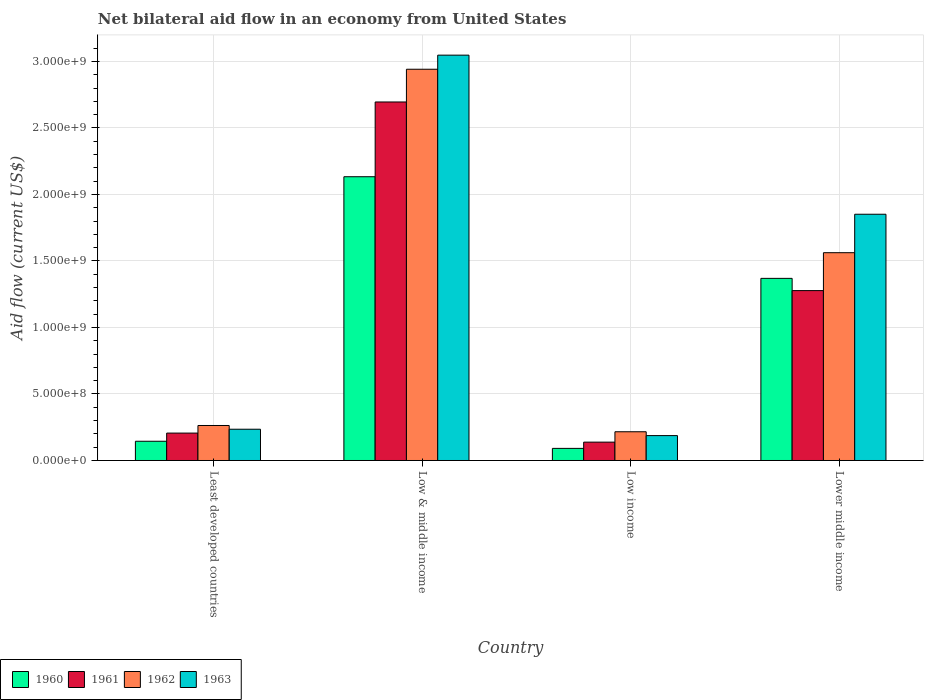How many different coloured bars are there?
Ensure brevity in your answer.  4. How many groups of bars are there?
Provide a short and direct response. 4. Are the number of bars per tick equal to the number of legend labels?
Offer a very short reply. Yes. Are the number of bars on each tick of the X-axis equal?
Offer a very short reply. Yes. How many bars are there on the 4th tick from the right?
Provide a succinct answer. 4. What is the label of the 2nd group of bars from the left?
Provide a short and direct response. Low & middle income. In how many cases, is the number of bars for a given country not equal to the number of legend labels?
Ensure brevity in your answer.  0. What is the net bilateral aid flow in 1962 in Least developed countries?
Keep it short and to the point. 2.63e+08. Across all countries, what is the maximum net bilateral aid flow in 1962?
Keep it short and to the point. 2.94e+09. Across all countries, what is the minimum net bilateral aid flow in 1960?
Give a very brief answer. 9.10e+07. In which country was the net bilateral aid flow in 1961 minimum?
Offer a terse response. Low income. What is the total net bilateral aid flow in 1963 in the graph?
Your answer should be compact. 5.32e+09. What is the difference between the net bilateral aid flow in 1963 in Least developed countries and that in Lower middle income?
Give a very brief answer. -1.62e+09. What is the difference between the net bilateral aid flow in 1960 in Low & middle income and the net bilateral aid flow in 1963 in Least developed countries?
Your answer should be compact. 1.90e+09. What is the average net bilateral aid flow in 1963 per country?
Provide a short and direct response. 1.33e+09. What is the difference between the net bilateral aid flow of/in 1962 and net bilateral aid flow of/in 1961 in Low & middle income?
Make the answer very short. 2.46e+08. In how many countries, is the net bilateral aid flow in 1962 greater than 2700000000 US$?
Give a very brief answer. 1. What is the ratio of the net bilateral aid flow in 1963 in Low & middle income to that in Lower middle income?
Your answer should be very brief. 1.65. What is the difference between the highest and the second highest net bilateral aid flow in 1960?
Your answer should be compact. 7.64e+08. What is the difference between the highest and the lowest net bilateral aid flow in 1960?
Provide a short and direct response. 2.04e+09. What does the 1st bar from the left in Lower middle income represents?
Offer a very short reply. 1960. What does the 4th bar from the right in Low income represents?
Ensure brevity in your answer.  1960. Is it the case that in every country, the sum of the net bilateral aid flow in 1960 and net bilateral aid flow in 1961 is greater than the net bilateral aid flow in 1963?
Provide a succinct answer. Yes. Are all the bars in the graph horizontal?
Ensure brevity in your answer.  No. How many countries are there in the graph?
Offer a very short reply. 4. What is the difference between two consecutive major ticks on the Y-axis?
Provide a short and direct response. 5.00e+08. How are the legend labels stacked?
Make the answer very short. Horizontal. What is the title of the graph?
Ensure brevity in your answer.  Net bilateral aid flow in an economy from United States. Does "1993" appear as one of the legend labels in the graph?
Your response must be concise. No. What is the label or title of the Y-axis?
Keep it short and to the point. Aid flow (current US$). What is the Aid flow (current US$) in 1960 in Least developed countries?
Offer a very short reply. 1.45e+08. What is the Aid flow (current US$) of 1961 in Least developed countries?
Give a very brief answer. 2.06e+08. What is the Aid flow (current US$) in 1962 in Least developed countries?
Your response must be concise. 2.63e+08. What is the Aid flow (current US$) of 1963 in Least developed countries?
Your answer should be compact. 2.35e+08. What is the Aid flow (current US$) in 1960 in Low & middle income?
Offer a very short reply. 2.13e+09. What is the Aid flow (current US$) of 1961 in Low & middle income?
Provide a succinct answer. 2.70e+09. What is the Aid flow (current US$) in 1962 in Low & middle income?
Make the answer very short. 2.94e+09. What is the Aid flow (current US$) of 1963 in Low & middle income?
Provide a succinct answer. 3.05e+09. What is the Aid flow (current US$) of 1960 in Low income?
Offer a very short reply. 9.10e+07. What is the Aid flow (current US$) in 1961 in Low income?
Give a very brief answer. 1.38e+08. What is the Aid flow (current US$) of 1962 in Low income?
Give a very brief answer. 2.16e+08. What is the Aid flow (current US$) in 1963 in Low income?
Give a very brief answer. 1.87e+08. What is the Aid flow (current US$) of 1960 in Lower middle income?
Provide a succinct answer. 1.37e+09. What is the Aid flow (current US$) of 1961 in Lower middle income?
Your answer should be very brief. 1.28e+09. What is the Aid flow (current US$) of 1962 in Lower middle income?
Your answer should be compact. 1.56e+09. What is the Aid flow (current US$) in 1963 in Lower middle income?
Offer a very short reply. 1.85e+09. Across all countries, what is the maximum Aid flow (current US$) of 1960?
Your answer should be very brief. 2.13e+09. Across all countries, what is the maximum Aid flow (current US$) of 1961?
Offer a very short reply. 2.70e+09. Across all countries, what is the maximum Aid flow (current US$) in 1962?
Your answer should be very brief. 2.94e+09. Across all countries, what is the maximum Aid flow (current US$) of 1963?
Make the answer very short. 3.05e+09. Across all countries, what is the minimum Aid flow (current US$) in 1960?
Offer a very short reply. 9.10e+07. Across all countries, what is the minimum Aid flow (current US$) in 1961?
Make the answer very short. 1.38e+08. Across all countries, what is the minimum Aid flow (current US$) of 1962?
Provide a succinct answer. 2.16e+08. Across all countries, what is the minimum Aid flow (current US$) in 1963?
Provide a succinct answer. 1.87e+08. What is the total Aid flow (current US$) in 1960 in the graph?
Ensure brevity in your answer.  3.74e+09. What is the total Aid flow (current US$) of 1961 in the graph?
Provide a succinct answer. 4.32e+09. What is the total Aid flow (current US$) of 1962 in the graph?
Your answer should be compact. 4.98e+09. What is the total Aid flow (current US$) in 1963 in the graph?
Offer a very short reply. 5.32e+09. What is the difference between the Aid flow (current US$) in 1960 in Least developed countries and that in Low & middle income?
Your answer should be compact. -1.99e+09. What is the difference between the Aid flow (current US$) in 1961 in Least developed countries and that in Low & middle income?
Ensure brevity in your answer.  -2.49e+09. What is the difference between the Aid flow (current US$) of 1962 in Least developed countries and that in Low & middle income?
Your response must be concise. -2.68e+09. What is the difference between the Aid flow (current US$) in 1963 in Least developed countries and that in Low & middle income?
Keep it short and to the point. -2.81e+09. What is the difference between the Aid flow (current US$) of 1960 in Least developed countries and that in Low income?
Ensure brevity in your answer.  5.35e+07. What is the difference between the Aid flow (current US$) of 1961 in Least developed countries and that in Low income?
Offer a terse response. 6.80e+07. What is the difference between the Aid flow (current US$) in 1962 in Least developed countries and that in Low income?
Your response must be concise. 4.70e+07. What is the difference between the Aid flow (current US$) in 1963 in Least developed countries and that in Low income?
Your response must be concise. 4.80e+07. What is the difference between the Aid flow (current US$) of 1960 in Least developed countries and that in Lower middle income?
Your answer should be compact. -1.22e+09. What is the difference between the Aid flow (current US$) of 1961 in Least developed countries and that in Lower middle income?
Offer a terse response. -1.07e+09. What is the difference between the Aid flow (current US$) of 1962 in Least developed countries and that in Lower middle income?
Keep it short and to the point. -1.30e+09. What is the difference between the Aid flow (current US$) in 1963 in Least developed countries and that in Lower middle income?
Ensure brevity in your answer.  -1.62e+09. What is the difference between the Aid flow (current US$) of 1960 in Low & middle income and that in Low income?
Offer a terse response. 2.04e+09. What is the difference between the Aid flow (current US$) of 1961 in Low & middle income and that in Low income?
Offer a terse response. 2.56e+09. What is the difference between the Aid flow (current US$) in 1962 in Low & middle income and that in Low income?
Give a very brief answer. 2.72e+09. What is the difference between the Aid flow (current US$) in 1963 in Low & middle income and that in Low income?
Your answer should be compact. 2.86e+09. What is the difference between the Aid flow (current US$) of 1960 in Low & middle income and that in Lower middle income?
Provide a succinct answer. 7.64e+08. What is the difference between the Aid flow (current US$) of 1961 in Low & middle income and that in Lower middle income?
Your answer should be very brief. 1.42e+09. What is the difference between the Aid flow (current US$) in 1962 in Low & middle income and that in Lower middle income?
Your response must be concise. 1.38e+09. What is the difference between the Aid flow (current US$) in 1963 in Low & middle income and that in Lower middle income?
Your answer should be very brief. 1.20e+09. What is the difference between the Aid flow (current US$) of 1960 in Low income and that in Lower middle income?
Keep it short and to the point. -1.28e+09. What is the difference between the Aid flow (current US$) in 1961 in Low income and that in Lower middle income?
Your response must be concise. -1.14e+09. What is the difference between the Aid flow (current US$) of 1962 in Low income and that in Lower middle income?
Ensure brevity in your answer.  -1.35e+09. What is the difference between the Aid flow (current US$) of 1963 in Low income and that in Lower middle income?
Keep it short and to the point. -1.66e+09. What is the difference between the Aid flow (current US$) in 1960 in Least developed countries and the Aid flow (current US$) in 1961 in Low & middle income?
Provide a short and direct response. -2.55e+09. What is the difference between the Aid flow (current US$) of 1960 in Least developed countries and the Aid flow (current US$) of 1962 in Low & middle income?
Ensure brevity in your answer.  -2.80e+09. What is the difference between the Aid flow (current US$) in 1960 in Least developed countries and the Aid flow (current US$) in 1963 in Low & middle income?
Your response must be concise. -2.90e+09. What is the difference between the Aid flow (current US$) of 1961 in Least developed countries and the Aid flow (current US$) of 1962 in Low & middle income?
Give a very brief answer. -2.74e+09. What is the difference between the Aid flow (current US$) of 1961 in Least developed countries and the Aid flow (current US$) of 1963 in Low & middle income?
Give a very brief answer. -2.84e+09. What is the difference between the Aid flow (current US$) of 1962 in Least developed countries and the Aid flow (current US$) of 1963 in Low & middle income?
Give a very brief answer. -2.78e+09. What is the difference between the Aid flow (current US$) in 1960 in Least developed countries and the Aid flow (current US$) in 1961 in Low income?
Provide a short and direct response. 6.52e+06. What is the difference between the Aid flow (current US$) in 1960 in Least developed countries and the Aid flow (current US$) in 1962 in Low income?
Offer a terse response. -7.15e+07. What is the difference between the Aid flow (current US$) of 1960 in Least developed countries and the Aid flow (current US$) of 1963 in Low income?
Ensure brevity in your answer.  -4.25e+07. What is the difference between the Aid flow (current US$) of 1961 in Least developed countries and the Aid flow (current US$) of 1962 in Low income?
Provide a succinct answer. -1.00e+07. What is the difference between the Aid flow (current US$) of 1961 in Least developed countries and the Aid flow (current US$) of 1963 in Low income?
Provide a succinct answer. 1.90e+07. What is the difference between the Aid flow (current US$) in 1962 in Least developed countries and the Aid flow (current US$) in 1963 in Low income?
Your answer should be very brief. 7.60e+07. What is the difference between the Aid flow (current US$) in 1960 in Least developed countries and the Aid flow (current US$) in 1961 in Lower middle income?
Your response must be concise. -1.13e+09. What is the difference between the Aid flow (current US$) in 1960 in Least developed countries and the Aid flow (current US$) in 1962 in Lower middle income?
Offer a terse response. -1.42e+09. What is the difference between the Aid flow (current US$) in 1960 in Least developed countries and the Aid flow (current US$) in 1963 in Lower middle income?
Your answer should be compact. -1.71e+09. What is the difference between the Aid flow (current US$) of 1961 in Least developed countries and the Aid flow (current US$) of 1962 in Lower middle income?
Offer a terse response. -1.36e+09. What is the difference between the Aid flow (current US$) of 1961 in Least developed countries and the Aid flow (current US$) of 1963 in Lower middle income?
Give a very brief answer. -1.64e+09. What is the difference between the Aid flow (current US$) in 1962 in Least developed countries and the Aid flow (current US$) in 1963 in Lower middle income?
Provide a succinct answer. -1.59e+09. What is the difference between the Aid flow (current US$) in 1960 in Low & middle income and the Aid flow (current US$) in 1961 in Low income?
Offer a terse response. 2.00e+09. What is the difference between the Aid flow (current US$) of 1960 in Low & middle income and the Aid flow (current US$) of 1962 in Low income?
Provide a succinct answer. 1.92e+09. What is the difference between the Aid flow (current US$) of 1960 in Low & middle income and the Aid flow (current US$) of 1963 in Low income?
Provide a short and direct response. 1.95e+09. What is the difference between the Aid flow (current US$) of 1961 in Low & middle income and the Aid flow (current US$) of 1962 in Low income?
Provide a short and direct response. 2.48e+09. What is the difference between the Aid flow (current US$) of 1961 in Low & middle income and the Aid flow (current US$) of 1963 in Low income?
Your answer should be very brief. 2.51e+09. What is the difference between the Aid flow (current US$) in 1962 in Low & middle income and the Aid flow (current US$) in 1963 in Low income?
Provide a short and direct response. 2.75e+09. What is the difference between the Aid flow (current US$) in 1960 in Low & middle income and the Aid flow (current US$) in 1961 in Lower middle income?
Provide a succinct answer. 8.56e+08. What is the difference between the Aid flow (current US$) in 1960 in Low & middle income and the Aid flow (current US$) in 1962 in Lower middle income?
Offer a terse response. 5.71e+08. What is the difference between the Aid flow (current US$) of 1960 in Low & middle income and the Aid flow (current US$) of 1963 in Lower middle income?
Offer a terse response. 2.82e+08. What is the difference between the Aid flow (current US$) of 1961 in Low & middle income and the Aid flow (current US$) of 1962 in Lower middle income?
Provide a short and direct response. 1.13e+09. What is the difference between the Aid flow (current US$) of 1961 in Low & middle income and the Aid flow (current US$) of 1963 in Lower middle income?
Offer a very short reply. 8.44e+08. What is the difference between the Aid flow (current US$) in 1962 in Low & middle income and the Aid flow (current US$) in 1963 in Lower middle income?
Your answer should be compact. 1.09e+09. What is the difference between the Aid flow (current US$) in 1960 in Low income and the Aid flow (current US$) in 1961 in Lower middle income?
Your answer should be very brief. -1.19e+09. What is the difference between the Aid flow (current US$) of 1960 in Low income and the Aid flow (current US$) of 1962 in Lower middle income?
Your answer should be very brief. -1.47e+09. What is the difference between the Aid flow (current US$) of 1960 in Low income and the Aid flow (current US$) of 1963 in Lower middle income?
Provide a short and direct response. -1.76e+09. What is the difference between the Aid flow (current US$) of 1961 in Low income and the Aid flow (current US$) of 1962 in Lower middle income?
Ensure brevity in your answer.  -1.42e+09. What is the difference between the Aid flow (current US$) of 1961 in Low income and the Aid flow (current US$) of 1963 in Lower middle income?
Provide a succinct answer. -1.71e+09. What is the difference between the Aid flow (current US$) in 1962 in Low income and the Aid flow (current US$) in 1963 in Lower middle income?
Give a very brief answer. -1.64e+09. What is the average Aid flow (current US$) of 1960 per country?
Keep it short and to the point. 9.34e+08. What is the average Aid flow (current US$) in 1961 per country?
Provide a succinct answer. 1.08e+09. What is the average Aid flow (current US$) of 1962 per country?
Your answer should be very brief. 1.25e+09. What is the average Aid flow (current US$) in 1963 per country?
Offer a terse response. 1.33e+09. What is the difference between the Aid flow (current US$) in 1960 and Aid flow (current US$) in 1961 in Least developed countries?
Keep it short and to the point. -6.15e+07. What is the difference between the Aid flow (current US$) in 1960 and Aid flow (current US$) in 1962 in Least developed countries?
Give a very brief answer. -1.18e+08. What is the difference between the Aid flow (current US$) of 1960 and Aid flow (current US$) of 1963 in Least developed countries?
Your answer should be very brief. -9.05e+07. What is the difference between the Aid flow (current US$) of 1961 and Aid flow (current US$) of 1962 in Least developed countries?
Make the answer very short. -5.70e+07. What is the difference between the Aid flow (current US$) in 1961 and Aid flow (current US$) in 1963 in Least developed countries?
Keep it short and to the point. -2.90e+07. What is the difference between the Aid flow (current US$) in 1962 and Aid flow (current US$) in 1963 in Least developed countries?
Your answer should be very brief. 2.80e+07. What is the difference between the Aid flow (current US$) in 1960 and Aid flow (current US$) in 1961 in Low & middle income?
Provide a succinct answer. -5.62e+08. What is the difference between the Aid flow (current US$) of 1960 and Aid flow (current US$) of 1962 in Low & middle income?
Give a very brief answer. -8.08e+08. What is the difference between the Aid flow (current US$) of 1960 and Aid flow (current US$) of 1963 in Low & middle income?
Provide a succinct answer. -9.14e+08. What is the difference between the Aid flow (current US$) in 1961 and Aid flow (current US$) in 1962 in Low & middle income?
Your response must be concise. -2.46e+08. What is the difference between the Aid flow (current US$) in 1961 and Aid flow (current US$) in 1963 in Low & middle income?
Offer a very short reply. -3.52e+08. What is the difference between the Aid flow (current US$) in 1962 and Aid flow (current US$) in 1963 in Low & middle income?
Your answer should be compact. -1.06e+08. What is the difference between the Aid flow (current US$) in 1960 and Aid flow (current US$) in 1961 in Low income?
Keep it short and to the point. -4.70e+07. What is the difference between the Aid flow (current US$) in 1960 and Aid flow (current US$) in 1962 in Low income?
Offer a very short reply. -1.25e+08. What is the difference between the Aid flow (current US$) of 1960 and Aid flow (current US$) of 1963 in Low income?
Offer a terse response. -9.60e+07. What is the difference between the Aid flow (current US$) of 1961 and Aid flow (current US$) of 1962 in Low income?
Provide a succinct answer. -7.80e+07. What is the difference between the Aid flow (current US$) in 1961 and Aid flow (current US$) in 1963 in Low income?
Keep it short and to the point. -4.90e+07. What is the difference between the Aid flow (current US$) of 1962 and Aid flow (current US$) of 1963 in Low income?
Keep it short and to the point. 2.90e+07. What is the difference between the Aid flow (current US$) in 1960 and Aid flow (current US$) in 1961 in Lower middle income?
Make the answer very short. 9.20e+07. What is the difference between the Aid flow (current US$) of 1960 and Aid flow (current US$) of 1962 in Lower middle income?
Provide a short and direct response. -1.93e+08. What is the difference between the Aid flow (current US$) of 1960 and Aid flow (current US$) of 1963 in Lower middle income?
Ensure brevity in your answer.  -4.82e+08. What is the difference between the Aid flow (current US$) in 1961 and Aid flow (current US$) in 1962 in Lower middle income?
Ensure brevity in your answer.  -2.85e+08. What is the difference between the Aid flow (current US$) of 1961 and Aid flow (current US$) of 1963 in Lower middle income?
Offer a very short reply. -5.74e+08. What is the difference between the Aid flow (current US$) of 1962 and Aid flow (current US$) of 1963 in Lower middle income?
Give a very brief answer. -2.89e+08. What is the ratio of the Aid flow (current US$) in 1960 in Least developed countries to that in Low & middle income?
Provide a succinct answer. 0.07. What is the ratio of the Aid flow (current US$) of 1961 in Least developed countries to that in Low & middle income?
Provide a short and direct response. 0.08. What is the ratio of the Aid flow (current US$) of 1962 in Least developed countries to that in Low & middle income?
Your answer should be compact. 0.09. What is the ratio of the Aid flow (current US$) in 1963 in Least developed countries to that in Low & middle income?
Your response must be concise. 0.08. What is the ratio of the Aid flow (current US$) in 1960 in Least developed countries to that in Low income?
Offer a terse response. 1.59. What is the ratio of the Aid flow (current US$) in 1961 in Least developed countries to that in Low income?
Your answer should be very brief. 1.49. What is the ratio of the Aid flow (current US$) of 1962 in Least developed countries to that in Low income?
Provide a succinct answer. 1.22. What is the ratio of the Aid flow (current US$) in 1963 in Least developed countries to that in Low income?
Your response must be concise. 1.26. What is the ratio of the Aid flow (current US$) in 1960 in Least developed countries to that in Lower middle income?
Make the answer very short. 0.11. What is the ratio of the Aid flow (current US$) of 1961 in Least developed countries to that in Lower middle income?
Provide a short and direct response. 0.16. What is the ratio of the Aid flow (current US$) in 1962 in Least developed countries to that in Lower middle income?
Your response must be concise. 0.17. What is the ratio of the Aid flow (current US$) of 1963 in Least developed countries to that in Lower middle income?
Provide a short and direct response. 0.13. What is the ratio of the Aid flow (current US$) in 1960 in Low & middle income to that in Low income?
Make the answer very short. 23.44. What is the ratio of the Aid flow (current US$) of 1961 in Low & middle income to that in Low income?
Your response must be concise. 19.53. What is the ratio of the Aid flow (current US$) in 1962 in Low & middle income to that in Low income?
Offer a terse response. 13.62. What is the ratio of the Aid flow (current US$) in 1963 in Low & middle income to that in Low income?
Make the answer very short. 16.29. What is the ratio of the Aid flow (current US$) in 1960 in Low & middle income to that in Lower middle income?
Offer a terse response. 1.56. What is the ratio of the Aid flow (current US$) of 1961 in Low & middle income to that in Lower middle income?
Offer a terse response. 2.11. What is the ratio of the Aid flow (current US$) of 1962 in Low & middle income to that in Lower middle income?
Offer a very short reply. 1.88. What is the ratio of the Aid flow (current US$) in 1963 in Low & middle income to that in Lower middle income?
Your answer should be compact. 1.65. What is the ratio of the Aid flow (current US$) of 1960 in Low income to that in Lower middle income?
Offer a terse response. 0.07. What is the ratio of the Aid flow (current US$) in 1961 in Low income to that in Lower middle income?
Provide a short and direct response. 0.11. What is the ratio of the Aid flow (current US$) of 1962 in Low income to that in Lower middle income?
Make the answer very short. 0.14. What is the ratio of the Aid flow (current US$) in 1963 in Low income to that in Lower middle income?
Make the answer very short. 0.1. What is the difference between the highest and the second highest Aid flow (current US$) in 1960?
Your answer should be compact. 7.64e+08. What is the difference between the highest and the second highest Aid flow (current US$) of 1961?
Keep it short and to the point. 1.42e+09. What is the difference between the highest and the second highest Aid flow (current US$) in 1962?
Make the answer very short. 1.38e+09. What is the difference between the highest and the second highest Aid flow (current US$) of 1963?
Give a very brief answer. 1.20e+09. What is the difference between the highest and the lowest Aid flow (current US$) in 1960?
Offer a very short reply. 2.04e+09. What is the difference between the highest and the lowest Aid flow (current US$) of 1961?
Offer a very short reply. 2.56e+09. What is the difference between the highest and the lowest Aid flow (current US$) in 1962?
Your answer should be very brief. 2.72e+09. What is the difference between the highest and the lowest Aid flow (current US$) of 1963?
Your response must be concise. 2.86e+09. 